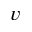<formula> <loc_0><loc_0><loc_500><loc_500>v</formula> 